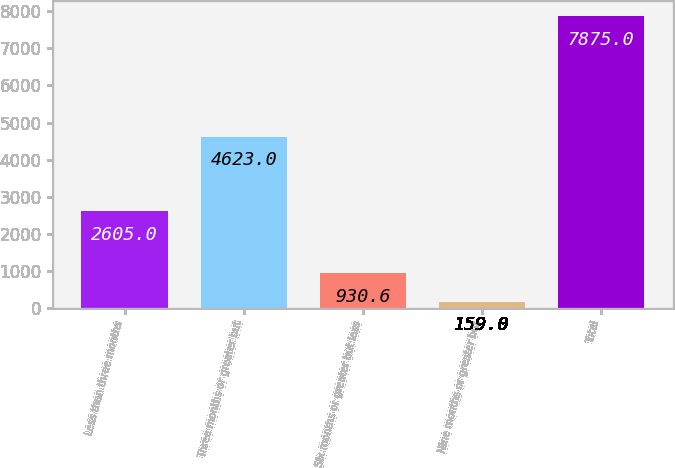Convert chart. <chart><loc_0><loc_0><loc_500><loc_500><bar_chart><fcel>Less than three months<fcel>Three months or greater but<fcel>Six months or greater but less<fcel>Nine months or greater but<fcel>Total<nl><fcel>2605<fcel>4623<fcel>930.6<fcel>159<fcel>7875<nl></chart> 